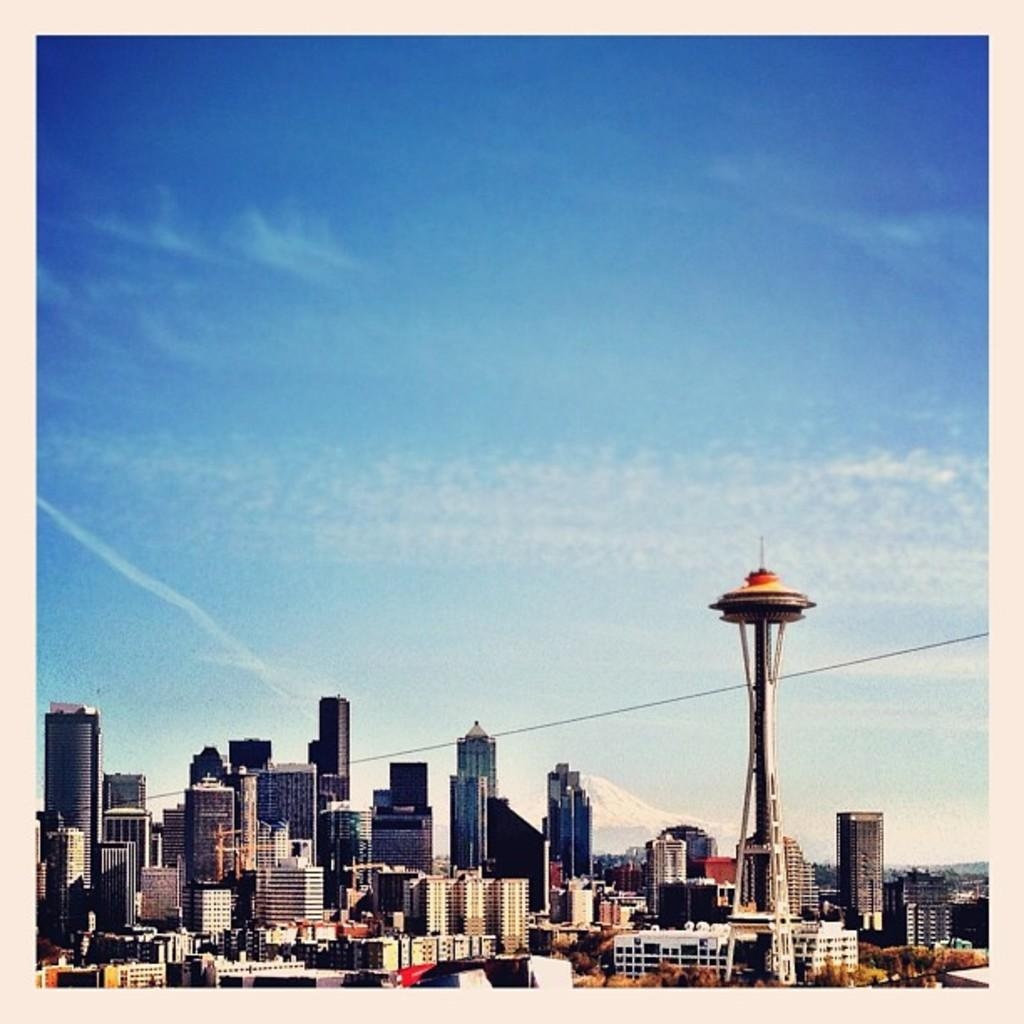What type of natural elements can be seen in the image? There are trees in the image. What type of man-made structures are present in the image? There are buildings and towers in the image. What type of geographical feature is visible in the image? There is a mountain in the image. What is visible in the sky in the image? The sky is visible in the image, and clouds are present. What type of rings can be seen on the fingers of the people in the image? There are no people present in the image, so there are no rings visible. What type of musical instrument is being played in the image? There is no musical instrument being played in the image. 